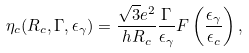<formula> <loc_0><loc_0><loc_500><loc_500>\eta _ { c } ( R _ { c } , \Gamma , \epsilon _ { \gamma } ) = \frac { \sqrt { 3 } e ^ { 2 } } { h R _ { c } } \frac { \Gamma } { \epsilon _ { \gamma } } F \left ( \frac { \epsilon _ { \gamma } } { \epsilon _ { c } } \right ) ,</formula> 